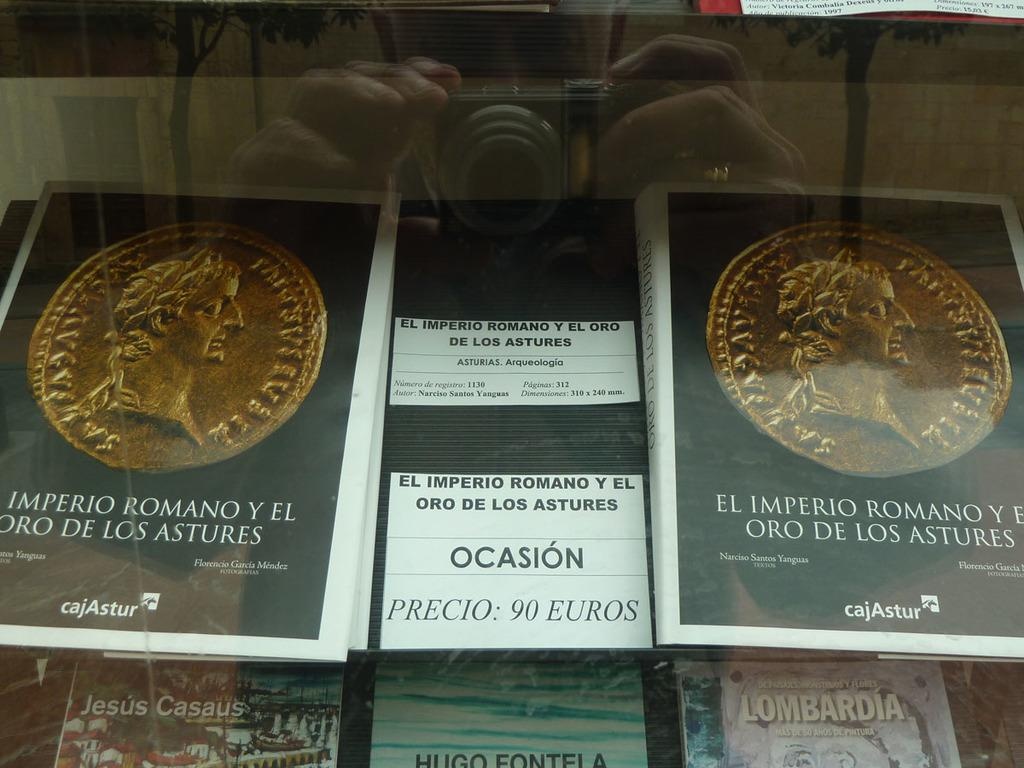<image>
Describe the image concisely. several books are on display under glass and for sale for 90 euros 